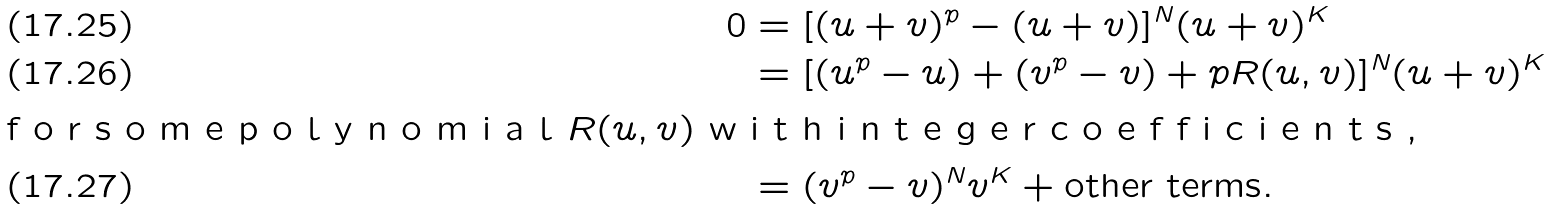<formula> <loc_0><loc_0><loc_500><loc_500>0 & = [ ( u + v ) ^ { p } - ( u + v ) ] ^ { N } ( u + v ) ^ { K } \\ & = [ ( u ^ { p } - u ) + ( v ^ { p } - v ) + p R ( u , v ) ] ^ { N } ( u + v ) ^ { K } \\ \intertext { f o r s o m e p o l y n o m i a l $ R ( u , v ) $ w i t h i n t e g e r c o e f f i c i e n t s , } & = ( v ^ { p } - v ) ^ { N } v ^ { K } + \text {other terms} .</formula> 